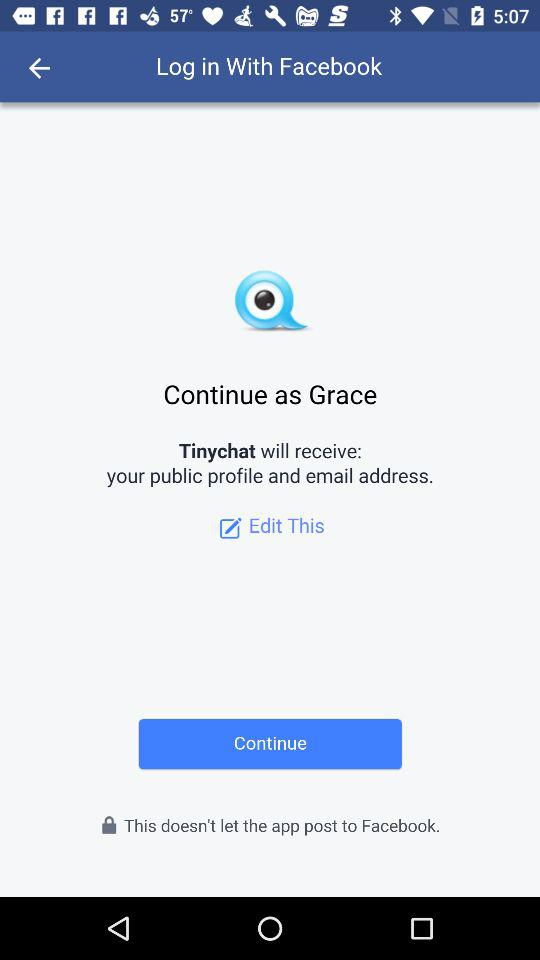Which profile can we use to log into Facebook?
When the provided information is insufficient, respond with <no answer>. <no answer> 